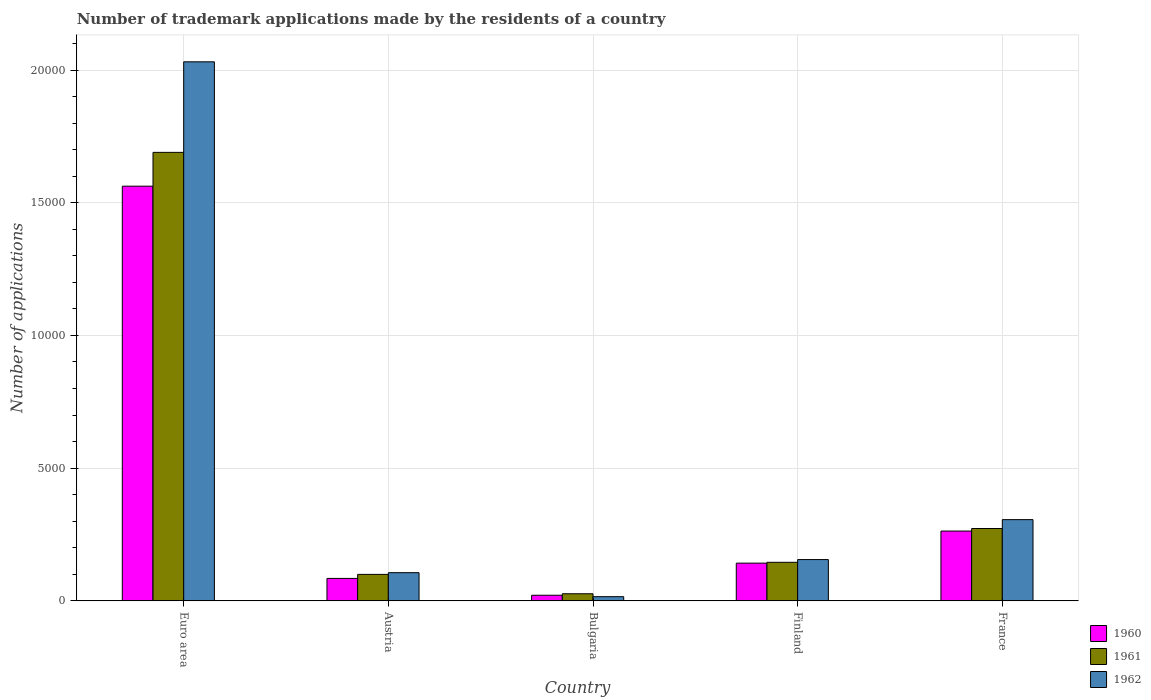How many different coloured bars are there?
Your answer should be compact. 3. Are the number of bars per tick equal to the number of legend labels?
Keep it short and to the point. Yes. How many bars are there on the 5th tick from the left?
Offer a very short reply. 3. How many bars are there on the 1st tick from the right?
Make the answer very short. 3. What is the label of the 3rd group of bars from the left?
Offer a terse response. Bulgaria. In how many cases, is the number of bars for a given country not equal to the number of legend labels?
Make the answer very short. 0. What is the number of trademark applications made by the residents in 1960 in France?
Your response must be concise. 2630. Across all countries, what is the maximum number of trademark applications made by the residents in 1960?
Make the answer very short. 1.56e+04. Across all countries, what is the minimum number of trademark applications made by the residents in 1962?
Keep it short and to the point. 157. In which country was the number of trademark applications made by the residents in 1962 maximum?
Ensure brevity in your answer.  Euro area. In which country was the number of trademark applications made by the residents in 1961 minimum?
Offer a very short reply. Bulgaria. What is the total number of trademark applications made by the residents in 1961 in the graph?
Provide a short and direct response. 2.23e+04. What is the difference between the number of trademark applications made by the residents in 1962 in Austria and that in Bulgaria?
Keep it short and to the point. 904. What is the difference between the number of trademark applications made by the residents in 1962 in Bulgaria and the number of trademark applications made by the residents in 1960 in Finland?
Offer a terse response. -1264. What is the average number of trademark applications made by the residents in 1961 per country?
Offer a very short reply. 4468.2. What is the difference between the number of trademark applications made by the residents of/in 1960 and number of trademark applications made by the residents of/in 1962 in Euro area?
Provide a short and direct response. -4686. In how many countries, is the number of trademark applications made by the residents in 1960 greater than 4000?
Your answer should be compact. 1. What is the ratio of the number of trademark applications made by the residents in 1962 in Austria to that in France?
Make the answer very short. 0.35. Is the difference between the number of trademark applications made by the residents in 1960 in Austria and France greater than the difference between the number of trademark applications made by the residents in 1962 in Austria and France?
Give a very brief answer. Yes. What is the difference between the highest and the second highest number of trademark applications made by the residents in 1961?
Your answer should be compact. 1.54e+04. What is the difference between the highest and the lowest number of trademark applications made by the residents in 1960?
Provide a succinct answer. 1.54e+04. In how many countries, is the number of trademark applications made by the residents in 1960 greater than the average number of trademark applications made by the residents in 1960 taken over all countries?
Your answer should be very brief. 1. Is the sum of the number of trademark applications made by the residents in 1960 in Austria and France greater than the maximum number of trademark applications made by the residents in 1962 across all countries?
Your answer should be very brief. No. What does the 2nd bar from the right in Finland represents?
Offer a very short reply. 1961. Is it the case that in every country, the sum of the number of trademark applications made by the residents in 1962 and number of trademark applications made by the residents in 1960 is greater than the number of trademark applications made by the residents in 1961?
Give a very brief answer. Yes. How many bars are there?
Give a very brief answer. 15. What is the difference between two consecutive major ticks on the Y-axis?
Make the answer very short. 5000. Are the values on the major ticks of Y-axis written in scientific E-notation?
Give a very brief answer. No. Does the graph contain grids?
Keep it short and to the point. Yes. How many legend labels are there?
Offer a very short reply. 3. How are the legend labels stacked?
Provide a short and direct response. Vertical. What is the title of the graph?
Offer a terse response. Number of trademark applications made by the residents of a country. What is the label or title of the X-axis?
Your answer should be compact. Country. What is the label or title of the Y-axis?
Give a very brief answer. Number of applications. What is the Number of applications of 1960 in Euro area?
Offer a terse response. 1.56e+04. What is the Number of applications of 1961 in Euro area?
Offer a terse response. 1.69e+04. What is the Number of applications of 1962 in Euro area?
Keep it short and to the point. 2.03e+04. What is the Number of applications in 1960 in Austria?
Make the answer very short. 845. What is the Number of applications in 1961 in Austria?
Ensure brevity in your answer.  997. What is the Number of applications in 1962 in Austria?
Provide a succinct answer. 1061. What is the Number of applications of 1960 in Bulgaria?
Offer a very short reply. 211. What is the Number of applications in 1961 in Bulgaria?
Ensure brevity in your answer.  267. What is the Number of applications of 1962 in Bulgaria?
Make the answer very short. 157. What is the Number of applications of 1960 in Finland?
Your answer should be compact. 1421. What is the Number of applications of 1961 in Finland?
Your response must be concise. 1452. What is the Number of applications in 1962 in Finland?
Your response must be concise. 1555. What is the Number of applications in 1960 in France?
Give a very brief answer. 2630. What is the Number of applications of 1961 in France?
Your response must be concise. 2726. What is the Number of applications of 1962 in France?
Provide a short and direct response. 3060. Across all countries, what is the maximum Number of applications in 1960?
Give a very brief answer. 1.56e+04. Across all countries, what is the maximum Number of applications in 1961?
Your response must be concise. 1.69e+04. Across all countries, what is the maximum Number of applications of 1962?
Your answer should be compact. 2.03e+04. Across all countries, what is the minimum Number of applications of 1960?
Keep it short and to the point. 211. Across all countries, what is the minimum Number of applications in 1961?
Give a very brief answer. 267. Across all countries, what is the minimum Number of applications in 1962?
Offer a terse response. 157. What is the total Number of applications in 1960 in the graph?
Give a very brief answer. 2.07e+04. What is the total Number of applications of 1961 in the graph?
Offer a terse response. 2.23e+04. What is the total Number of applications in 1962 in the graph?
Make the answer very short. 2.61e+04. What is the difference between the Number of applications in 1960 in Euro area and that in Austria?
Provide a succinct answer. 1.48e+04. What is the difference between the Number of applications of 1961 in Euro area and that in Austria?
Ensure brevity in your answer.  1.59e+04. What is the difference between the Number of applications of 1962 in Euro area and that in Austria?
Your answer should be very brief. 1.92e+04. What is the difference between the Number of applications of 1960 in Euro area and that in Bulgaria?
Your answer should be very brief. 1.54e+04. What is the difference between the Number of applications in 1961 in Euro area and that in Bulgaria?
Your response must be concise. 1.66e+04. What is the difference between the Number of applications of 1962 in Euro area and that in Bulgaria?
Your response must be concise. 2.02e+04. What is the difference between the Number of applications in 1960 in Euro area and that in Finland?
Your answer should be very brief. 1.42e+04. What is the difference between the Number of applications of 1961 in Euro area and that in Finland?
Provide a short and direct response. 1.54e+04. What is the difference between the Number of applications in 1962 in Euro area and that in Finland?
Make the answer very short. 1.88e+04. What is the difference between the Number of applications of 1960 in Euro area and that in France?
Keep it short and to the point. 1.30e+04. What is the difference between the Number of applications of 1961 in Euro area and that in France?
Make the answer very short. 1.42e+04. What is the difference between the Number of applications in 1962 in Euro area and that in France?
Your answer should be very brief. 1.73e+04. What is the difference between the Number of applications of 1960 in Austria and that in Bulgaria?
Your answer should be compact. 634. What is the difference between the Number of applications in 1961 in Austria and that in Bulgaria?
Keep it short and to the point. 730. What is the difference between the Number of applications in 1962 in Austria and that in Bulgaria?
Your answer should be very brief. 904. What is the difference between the Number of applications of 1960 in Austria and that in Finland?
Offer a very short reply. -576. What is the difference between the Number of applications in 1961 in Austria and that in Finland?
Provide a short and direct response. -455. What is the difference between the Number of applications in 1962 in Austria and that in Finland?
Your answer should be compact. -494. What is the difference between the Number of applications in 1960 in Austria and that in France?
Provide a succinct answer. -1785. What is the difference between the Number of applications in 1961 in Austria and that in France?
Give a very brief answer. -1729. What is the difference between the Number of applications in 1962 in Austria and that in France?
Make the answer very short. -1999. What is the difference between the Number of applications of 1960 in Bulgaria and that in Finland?
Provide a short and direct response. -1210. What is the difference between the Number of applications of 1961 in Bulgaria and that in Finland?
Make the answer very short. -1185. What is the difference between the Number of applications of 1962 in Bulgaria and that in Finland?
Your answer should be compact. -1398. What is the difference between the Number of applications of 1960 in Bulgaria and that in France?
Provide a short and direct response. -2419. What is the difference between the Number of applications of 1961 in Bulgaria and that in France?
Ensure brevity in your answer.  -2459. What is the difference between the Number of applications of 1962 in Bulgaria and that in France?
Give a very brief answer. -2903. What is the difference between the Number of applications of 1960 in Finland and that in France?
Provide a short and direct response. -1209. What is the difference between the Number of applications in 1961 in Finland and that in France?
Offer a terse response. -1274. What is the difference between the Number of applications of 1962 in Finland and that in France?
Offer a very short reply. -1505. What is the difference between the Number of applications of 1960 in Euro area and the Number of applications of 1961 in Austria?
Keep it short and to the point. 1.46e+04. What is the difference between the Number of applications in 1960 in Euro area and the Number of applications in 1962 in Austria?
Offer a terse response. 1.46e+04. What is the difference between the Number of applications in 1961 in Euro area and the Number of applications in 1962 in Austria?
Provide a short and direct response. 1.58e+04. What is the difference between the Number of applications in 1960 in Euro area and the Number of applications in 1961 in Bulgaria?
Offer a terse response. 1.54e+04. What is the difference between the Number of applications in 1960 in Euro area and the Number of applications in 1962 in Bulgaria?
Provide a short and direct response. 1.55e+04. What is the difference between the Number of applications in 1961 in Euro area and the Number of applications in 1962 in Bulgaria?
Your answer should be compact. 1.67e+04. What is the difference between the Number of applications of 1960 in Euro area and the Number of applications of 1961 in Finland?
Your response must be concise. 1.42e+04. What is the difference between the Number of applications in 1960 in Euro area and the Number of applications in 1962 in Finland?
Your answer should be compact. 1.41e+04. What is the difference between the Number of applications of 1961 in Euro area and the Number of applications of 1962 in Finland?
Offer a very short reply. 1.53e+04. What is the difference between the Number of applications in 1960 in Euro area and the Number of applications in 1961 in France?
Make the answer very short. 1.29e+04. What is the difference between the Number of applications in 1960 in Euro area and the Number of applications in 1962 in France?
Keep it short and to the point. 1.26e+04. What is the difference between the Number of applications of 1961 in Euro area and the Number of applications of 1962 in France?
Provide a short and direct response. 1.38e+04. What is the difference between the Number of applications in 1960 in Austria and the Number of applications in 1961 in Bulgaria?
Keep it short and to the point. 578. What is the difference between the Number of applications in 1960 in Austria and the Number of applications in 1962 in Bulgaria?
Provide a succinct answer. 688. What is the difference between the Number of applications in 1961 in Austria and the Number of applications in 1962 in Bulgaria?
Your answer should be very brief. 840. What is the difference between the Number of applications of 1960 in Austria and the Number of applications of 1961 in Finland?
Your answer should be very brief. -607. What is the difference between the Number of applications of 1960 in Austria and the Number of applications of 1962 in Finland?
Your answer should be very brief. -710. What is the difference between the Number of applications in 1961 in Austria and the Number of applications in 1962 in Finland?
Ensure brevity in your answer.  -558. What is the difference between the Number of applications in 1960 in Austria and the Number of applications in 1961 in France?
Your answer should be compact. -1881. What is the difference between the Number of applications of 1960 in Austria and the Number of applications of 1962 in France?
Give a very brief answer. -2215. What is the difference between the Number of applications of 1961 in Austria and the Number of applications of 1962 in France?
Your response must be concise. -2063. What is the difference between the Number of applications in 1960 in Bulgaria and the Number of applications in 1961 in Finland?
Offer a terse response. -1241. What is the difference between the Number of applications in 1960 in Bulgaria and the Number of applications in 1962 in Finland?
Offer a terse response. -1344. What is the difference between the Number of applications of 1961 in Bulgaria and the Number of applications of 1962 in Finland?
Your response must be concise. -1288. What is the difference between the Number of applications in 1960 in Bulgaria and the Number of applications in 1961 in France?
Your answer should be very brief. -2515. What is the difference between the Number of applications of 1960 in Bulgaria and the Number of applications of 1962 in France?
Make the answer very short. -2849. What is the difference between the Number of applications of 1961 in Bulgaria and the Number of applications of 1962 in France?
Give a very brief answer. -2793. What is the difference between the Number of applications in 1960 in Finland and the Number of applications in 1961 in France?
Your answer should be compact. -1305. What is the difference between the Number of applications of 1960 in Finland and the Number of applications of 1962 in France?
Offer a terse response. -1639. What is the difference between the Number of applications of 1961 in Finland and the Number of applications of 1962 in France?
Offer a very short reply. -1608. What is the average Number of applications of 1960 per country?
Provide a succinct answer. 4146.4. What is the average Number of applications in 1961 per country?
Make the answer very short. 4468.2. What is the average Number of applications in 1962 per country?
Provide a short and direct response. 5228.8. What is the difference between the Number of applications of 1960 and Number of applications of 1961 in Euro area?
Give a very brief answer. -1274. What is the difference between the Number of applications in 1960 and Number of applications in 1962 in Euro area?
Keep it short and to the point. -4686. What is the difference between the Number of applications in 1961 and Number of applications in 1962 in Euro area?
Ensure brevity in your answer.  -3412. What is the difference between the Number of applications in 1960 and Number of applications in 1961 in Austria?
Offer a very short reply. -152. What is the difference between the Number of applications in 1960 and Number of applications in 1962 in Austria?
Make the answer very short. -216. What is the difference between the Number of applications in 1961 and Number of applications in 1962 in Austria?
Make the answer very short. -64. What is the difference between the Number of applications in 1960 and Number of applications in 1961 in Bulgaria?
Offer a terse response. -56. What is the difference between the Number of applications in 1960 and Number of applications in 1962 in Bulgaria?
Give a very brief answer. 54. What is the difference between the Number of applications in 1961 and Number of applications in 1962 in Bulgaria?
Offer a terse response. 110. What is the difference between the Number of applications in 1960 and Number of applications in 1961 in Finland?
Your answer should be compact. -31. What is the difference between the Number of applications of 1960 and Number of applications of 1962 in Finland?
Keep it short and to the point. -134. What is the difference between the Number of applications of 1961 and Number of applications of 1962 in Finland?
Your response must be concise. -103. What is the difference between the Number of applications of 1960 and Number of applications of 1961 in France?
Your answer should be compact. -96. What is the difference between the Number of applications in 1960 and Number of applications in 1962 in France?
Your answer should be very brief. -430. What is the difference between the Number of applications in 1961 and Number of applications in 1962 in France?
Provide a succinct answer. -334. What is the ratio of the Number of applications in 1960 in Euro area to that in Austria?
Provide a short and direct response. 18.49. What is the ratio of the Number of applications of 1961 in Euro area to that in Austria?
Offer a very short reply. 16.95. What is the ratio of the Number of applications in 1962 in Euro area to that in Austria?
Ensure brevity in your answer.  19.14. What is the ratio of the Number of applications in 1960 in Euro area to that in Bulgaria?
Keep it short and to the point. 74.05. What is the ratio of the Number of applications of 1961 in Euro area to that in Bulgaria?
Give a very brief answer. 63.29. What is the ratio of the Number of applications of 1962 in Euro area to that in Bulgaria?
Provide a short and direct response. 129.37. What is the ratio of the Number of applications in 1960 in Euro area to that in Finland?
Your answer should be compact. 11. What is the ratio of the Number of applications of 1961 in Euro area to that in Finland?
Give a very brief answer. 11.64. What is the ratio of the Number of applications in 1962 in Euro area to that in Finland?
Your answer should be very brief. 13.06. What is the ratio of the Number of applications in 1960 in Euro area to that in France?
Your answer should be very brief. 5.94. What is the ratio of the Number of applications in 1961 in Euro area to that in France?
Keep it short and to the point. 6.2. What is the ratio of the Number of applications of 1962 in Euro area to that in France?
Give a very brief answer. 6.64. What is the ratio of the Number of applications in 1960 in Austria to that in Bulgaria?
Ensure brevity in your answer.  4. What is the ratio of the Number of applications of 1961 in Austria to that in Bulgaria?
Make the answer very short. 3.73. What is the ratio of the Number of applications in 1962 in Austria to that in Bulgaria?
Offer a terse response. 6.76. What is the ratio of the Number of applications of 1960 in Austria to that in Finland?
Provide a succinct answer. 0.59. What is the ratio of the Number of applications in 1961 in Austria to that in Finland?
Offer a very short reply. 0.69. What is the ratio of the Number of applications of 1962 in Austria to that in Finland?
Provide a short and direct response. 0.68. What is the ratio of the Number of applications in 1960 in Austria to that in France?
Provide a short and direct response. 0.32. What is the ratio of the Number of applications of 1961 in Austria to that in France?
Provide a succinct answer. 0.37. What is the ratio of the Number of applications of 1962 in Austria to that in France?
Offer a terse response. 0.35. What is the ratio of the Number of applications in 1960 in Bulgaria to that in Finland?
Make the answer very short. 0.15. What is the ratio of the Number of applications in 1961 in Bulgaria to that in Finland?
Make the answer very short. 0.18. What is the ratio of the Number of applications of 1962 in Bulgaria to that in Finland?
Make the answer very short. 0.1. What is the ratio of the Number of applications in 1960 in Bulgaria to that in France?
Offer a very short reply. 0.08. What is the ratio of the Number of applications in 1961 in Bulgaria to that in France?
Provide a short and direct response. 0.1. What is the ratio of the Number of applications of 1962 in Bulgaria to that in France?
Offer a very short reply. 0.05. What is the ratio of the Number of applications of 1960 in Finland to that in France?
Ensure brevity in your answer.  0.54. What is the ratio of the Number of applications in 1961 in Finland to that in France?
Offer a very short reply. 0.53. What is the ratio of the Number of applications of 1962 in Finland to that in France?
Provide a short and direct response. 0.51. What is the difference between the highest and the second highest Number of applications in 1960?
Offer a terse response. 1.30e+04. What is the difference between the highest and the second highest Number of applications of 1961?
Offer a very short reply. 1.42e+04. What is the difference between the highest and the second highest Number of applications in 1962?
Your answer should be compact. 1.73e+04. What is the difference between the highest and the lowest Number of applications in 1960?
Offer a terse response. 1.54e+04. What is the difference between the highest and the lowest Number of applications of 1961?
Provide a succinct answer. 1.66e+04. What is the difference between the highest and the lowest Number of applications in 1962?
Offer a very short reply. 2.02e+04. 